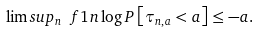<formula> <loc_0><loc_0><loc_500><loc_500>\lim s u p _ { n } \ f { 1 } { n } \log P \left [ \tau _ { n , a } < a \right ] \leq - a .</formula> 